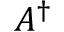<formula> <loc_0><loc_0><loc_500><loc_500>A ^ { \dagger }</formula> 